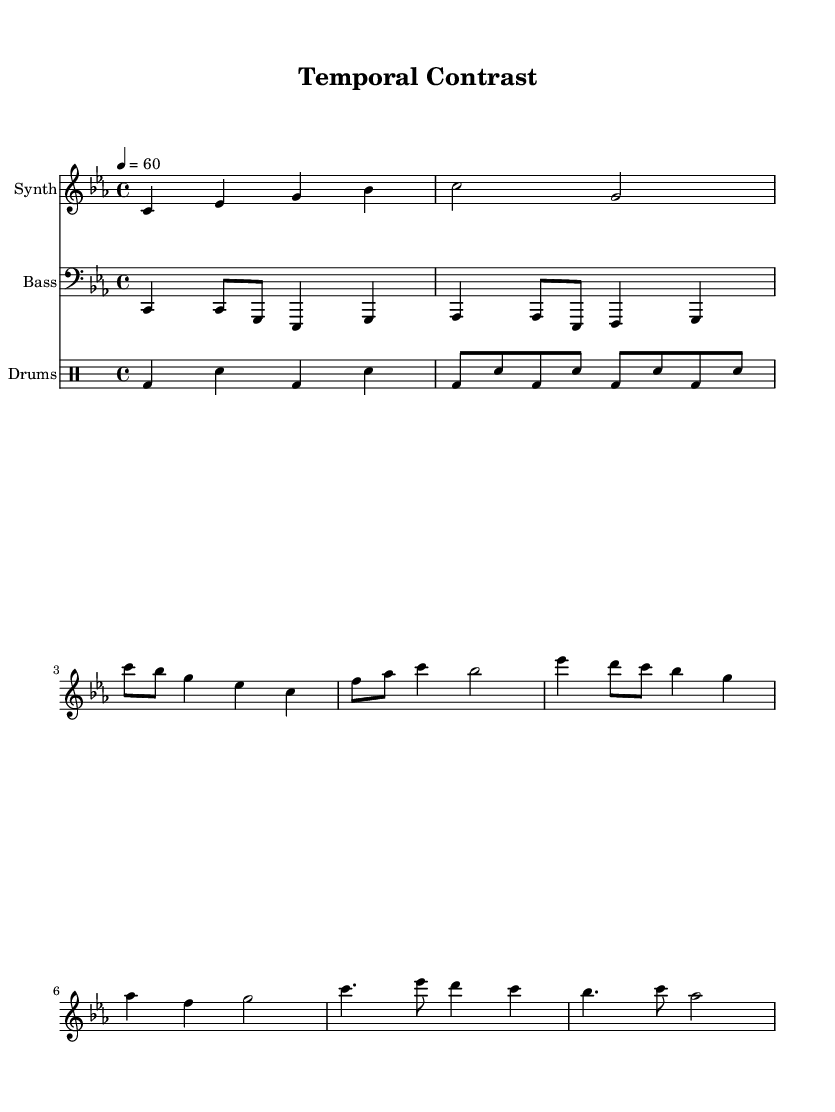What is the key signature of this music? The key signature is C minor, which has three flats (B, E, and A).
Answer: C minor What is the time signature used in this piece? The time signature is 4/4, indicating that there are four beats in each measure.
Answer: 4/4 What is the tempo marking for this composition? The tempo marking is "quarter note = 60," meaning there are 60 beats per minute.
Answer: 60 How many measures are in the intro section? The intro section contains 2 measures as indicated in the sheet music.
Answer: 2 measures What is the clef used for the bass part? The bass part uses the bass clef, which is designed for lower-pitched instruments.
Answer: Bass clef Which two sections feature a different rhythm pattern in the drum part? The intro features a different rhythm from the remaining sections, specifically highlighted with a varying kick/snare pattern in the first two measures.
Answer: Intro and remaining sections What is the highest note played in the synth part? The highest note played in the synth part is C' (middle-high C), which appears in the first verse measure.
Answer: C' 